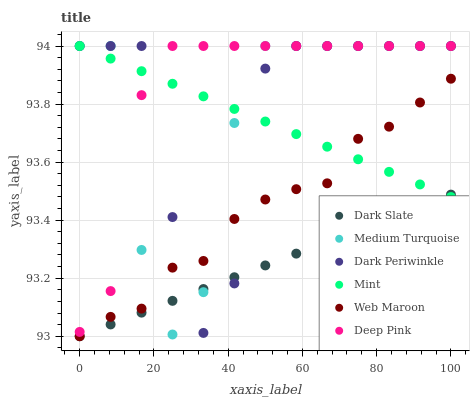Does Dark Slate have the minimum area under the curve?
Answer yes or no. Yes. Does Deep Pink have the maximum area under the curve?
Answer yes or no. Yes. Does Web Maroon have the minimum area under the curve?
Answer yes or no. No. Does Web Maroon have the maximum area under the curve?
Answer yes or no. No. Is Dark Slate the smoothest?
Answer yes or no. Yes. Is Dark Periwinkle the roughest?
Answer yes or no. Yes. Is Web Maroon the smoothest?
Answer yes or no. No. Is Web Maroon the roughest?
Answer yes or no. No. Does Web Maroon have the lowest value?
Answer yes or no. Yes. Does Medium Turquoise have the lowest value?
Answer yes or no. No. Does Dark Periwinkle have the highest value?
Answer yes or no. Yes. Does Web Maroon have the highest value?
Answer yes or no. No. Is Dark Slate less than Deep Pink?
Answer yes or no. Yes. Is Deep Pink greater than Dark Slate?
Answer yes or no. Yes. Does Dark Periwinkle intersect Deep Pink?
Answer yes or no. Yes. Is Dark Periwinkle less than Deep Pink?
Answer yes or no. No. Is Dark Periwinkle greater than Deep Pink?
Answer yes or no. No. Does Dark Slate intersect Deep Pink?
Answer yes or no. No. 